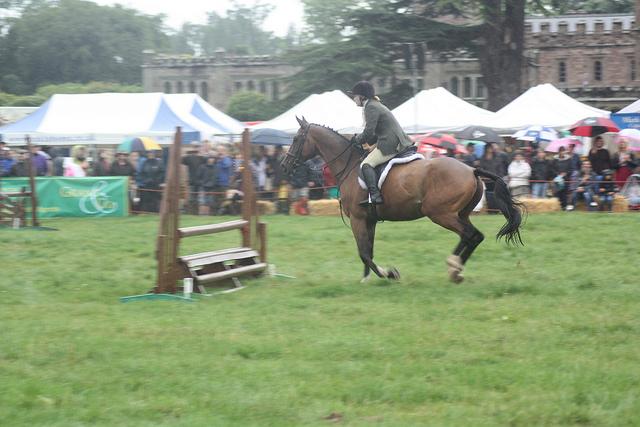Is the horse in a competition?
Quick response, please. Yes. How many tents are visible?
Quick response, please. 5. What kind of animal is shown?
Write a very short answer. Horse. 